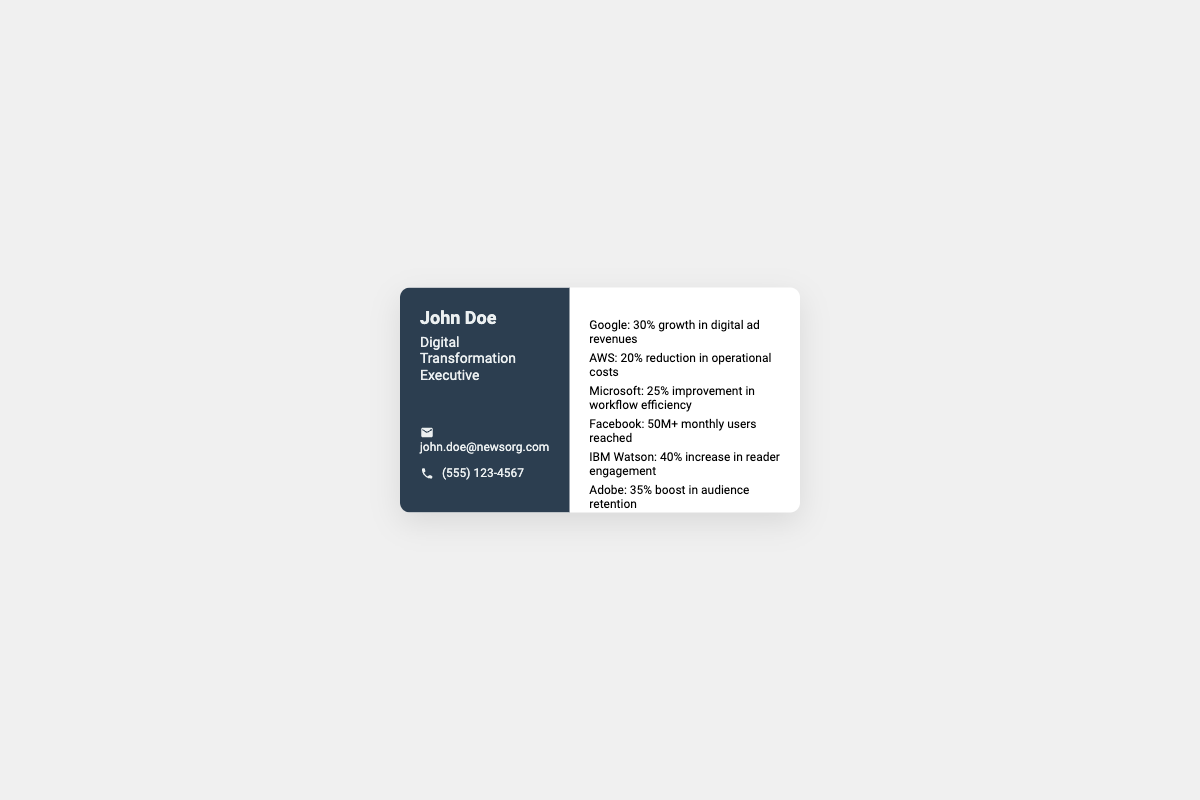what is John Doe's title? The title listed on the business card for John Doe is "Digital Transformation Executive."
Answer: Digital Transformation Executive how many strategic partnerships are listed? The document lists a total of six strategic partnerships.
Answer: 6 what percentage growth in digital ad revenues is attributed to Google? The document states that Google contributed to a 30% growth in digital ad revenues.
Answer: 30% which company contributed to a 50M+ monthly users reach? According to the document, Facebook is the company that reached 50M+ monthly users.
Answer: Facebook what is the improvement in workflow efficiency due to Microsoft? The document indicates a 25% improvement in workflow efficiency attributed to Microsoft.
Answer: 25% what was the reduction in operational costs with AWS? The document mentions a 20% reduction in operational costs from the AWS partnership.
Answer: 20% which technology company is associated with a 40% increase in reader engagement? IBM Watson is associated with the 40% increase in reader engagement as per the document.
Answer: IBM Watson which partnership resulted in a 35% boost in audience retention? The document states that Adobe led to a 35% boost in audience retention.
Answer: Adobe what is the primary role of John Doe as mentioned on the card? The primary role noted for John Doe is related to overseeing digital transformation initiatives.
Answer: overseeing digital transformation 